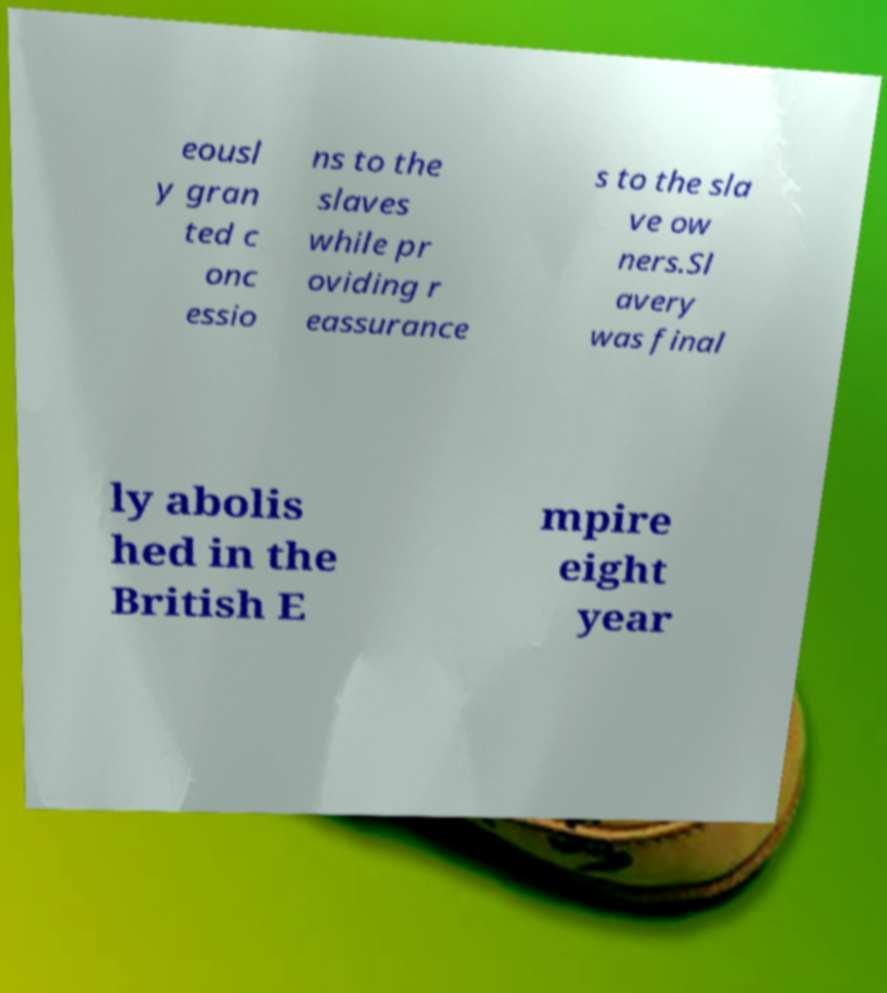Can you accurately transcribe the text from the provided image for me? eousl y gran ted c onc essio ns to the slaves while pr oviding r eassurance s to the sla ve ow ners.Sl avery was final ly abolis hed in the British E mpire eight year 